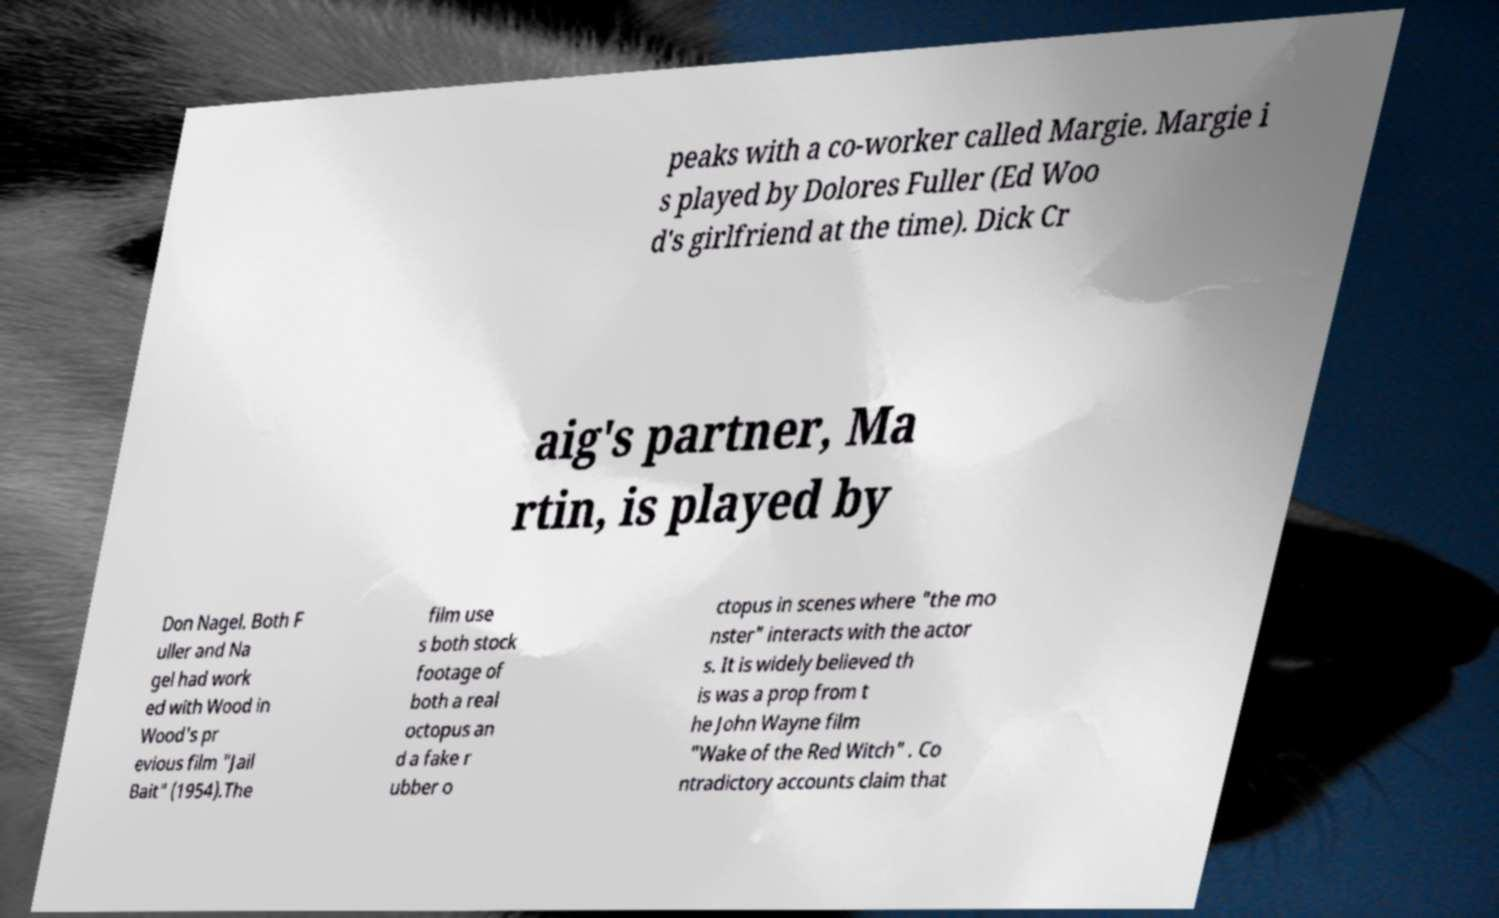What messages or text are displayed in this image? I need them in a readable, typed format. peaks with a co-worker called Margie. Margie i s played by Dolores Fuller (Ed Woo d's girlfriend at the time). Dick Cr aig's partner, Ma rtin, is played by Don Nagel. Both F uller and Na gel had work ed with Wood in Wood's pr evious film "Jail Bait" (1954).The film use s both stock footage of both a real octopus an d a fake r ubber o ctopus in scenes where "the mo nster" interacts with the actor s. It is widely believed th is was a prop from t he John Wayne film "Wake of the Red Witch" . Co ntradictory accounts claim that 